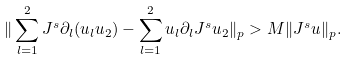Convert formula to latex. <formula><loc_0><loc_0><loc_500><loc_500>\| \sum _ { l = 1 } ^ { 2 } J ^ { s } \partial _ { l } ( u _ { l } u _ { 2 } ) - \sum _ { l = 1 } ^ { 2 } u _ { l } \partial _ { l } J ^ { s } u _ { 2 } \| _ { p } > M \| J ^ { s } u \| _ { p } .</formula> 